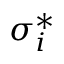Convert formula to latex. <formula><loc_0><loc_0><loc_500><loc_500>\sigma _ { i } ^ { * }</formula> 